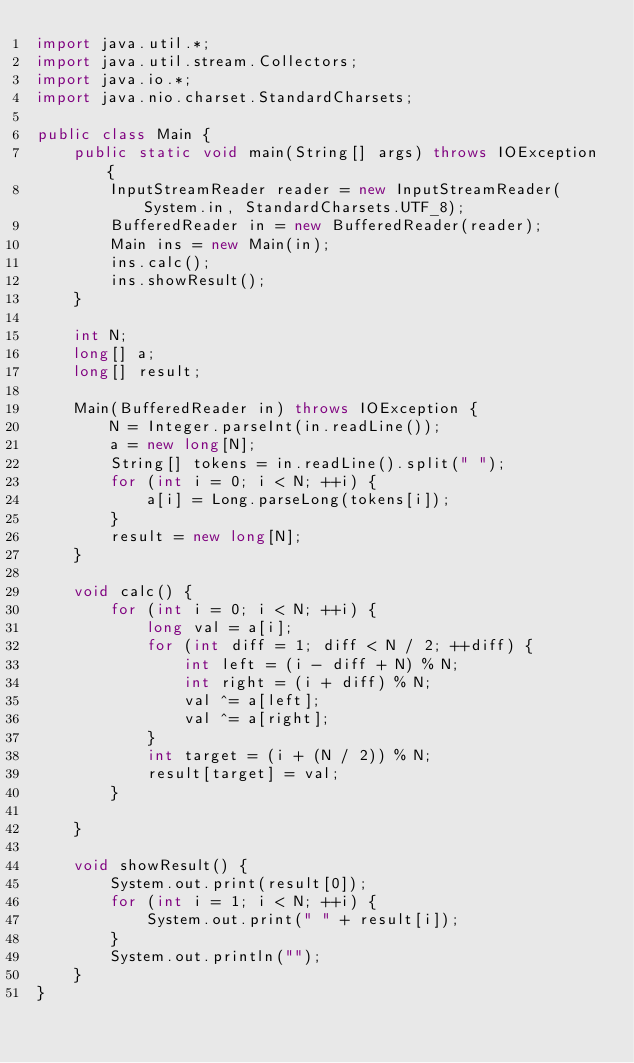<code> <loc_0><loc_0><loc_500><loc_500><_Java_>import java.util.*;
import java.util.stream.Collectors;
import java.io.*;
import java.nio.charset.StandardCharsets;

public class Main {
	public static void main(String[] args) throws IOException {
		InputStreamReader reader = new InputStreamReader(System.in, StandardCharsets.UTF_8);
		BufferedReader in = new BufferedReader(reader);
		Main ins = new Main(in);
		ins.calc();
		ins.showResult();
	}

	int N;
	long[] a;
	long[] result;

	Main(BufferedReader in) throws IOException {
		N = Integer.parseInt(in.readLine());
		a = new long[N];
		String[] tokens = in.readLine().split(" ");
		for (int i = 0; i < N; ++i) {
			a[i] = Long.parseLong(tokens[i]);
		}
		result = new long[N];
	}

	void calc() {
		for (int i = 0; i < N; ++i) {
			long val = a[i];
			for (int diff = 1; diff < N / 2; ++diff) {
				int left = (i - diff + N) % N;
				int right = (i + diff) % N;
				val ^= a[left];
				val ^= a[right];
			}
			int target = (i + (N / 2)) % N;
			result[target] = val;
		}

	}

	void showResult() {
		System.out.print(result[0]);
		for (int i = 1; i < N; ++i) {
			System.out.print(" " + result[i]);
		}
		System.out.println("");
	}
}
</code> 